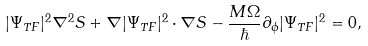<formula> <loc_0><loc_0><loc_500><loc_500>| \Psi _ { T F } | ^ { 2 } \nabla ^ { 2 } S + \nabla | \Psi _ { T F } | ^ { 2 } \cdot \nabla S - \frac { M \Omega } \hbar { \partial } _ { \phi } | \Psi _ { T F } | ^ { 2 } = 0 ,</formula> 